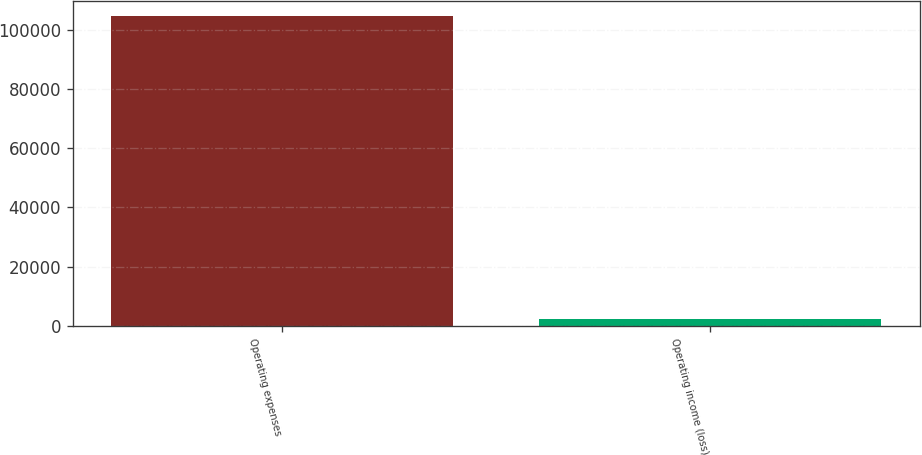Convert chart. <chart><loc_0><loc_0><loc_500><loc_500><bar_chart><fcel>Operating expenses<fcel>Operating income (loss)<nl><fcel>104773<fcel>2233<nl></chart> 